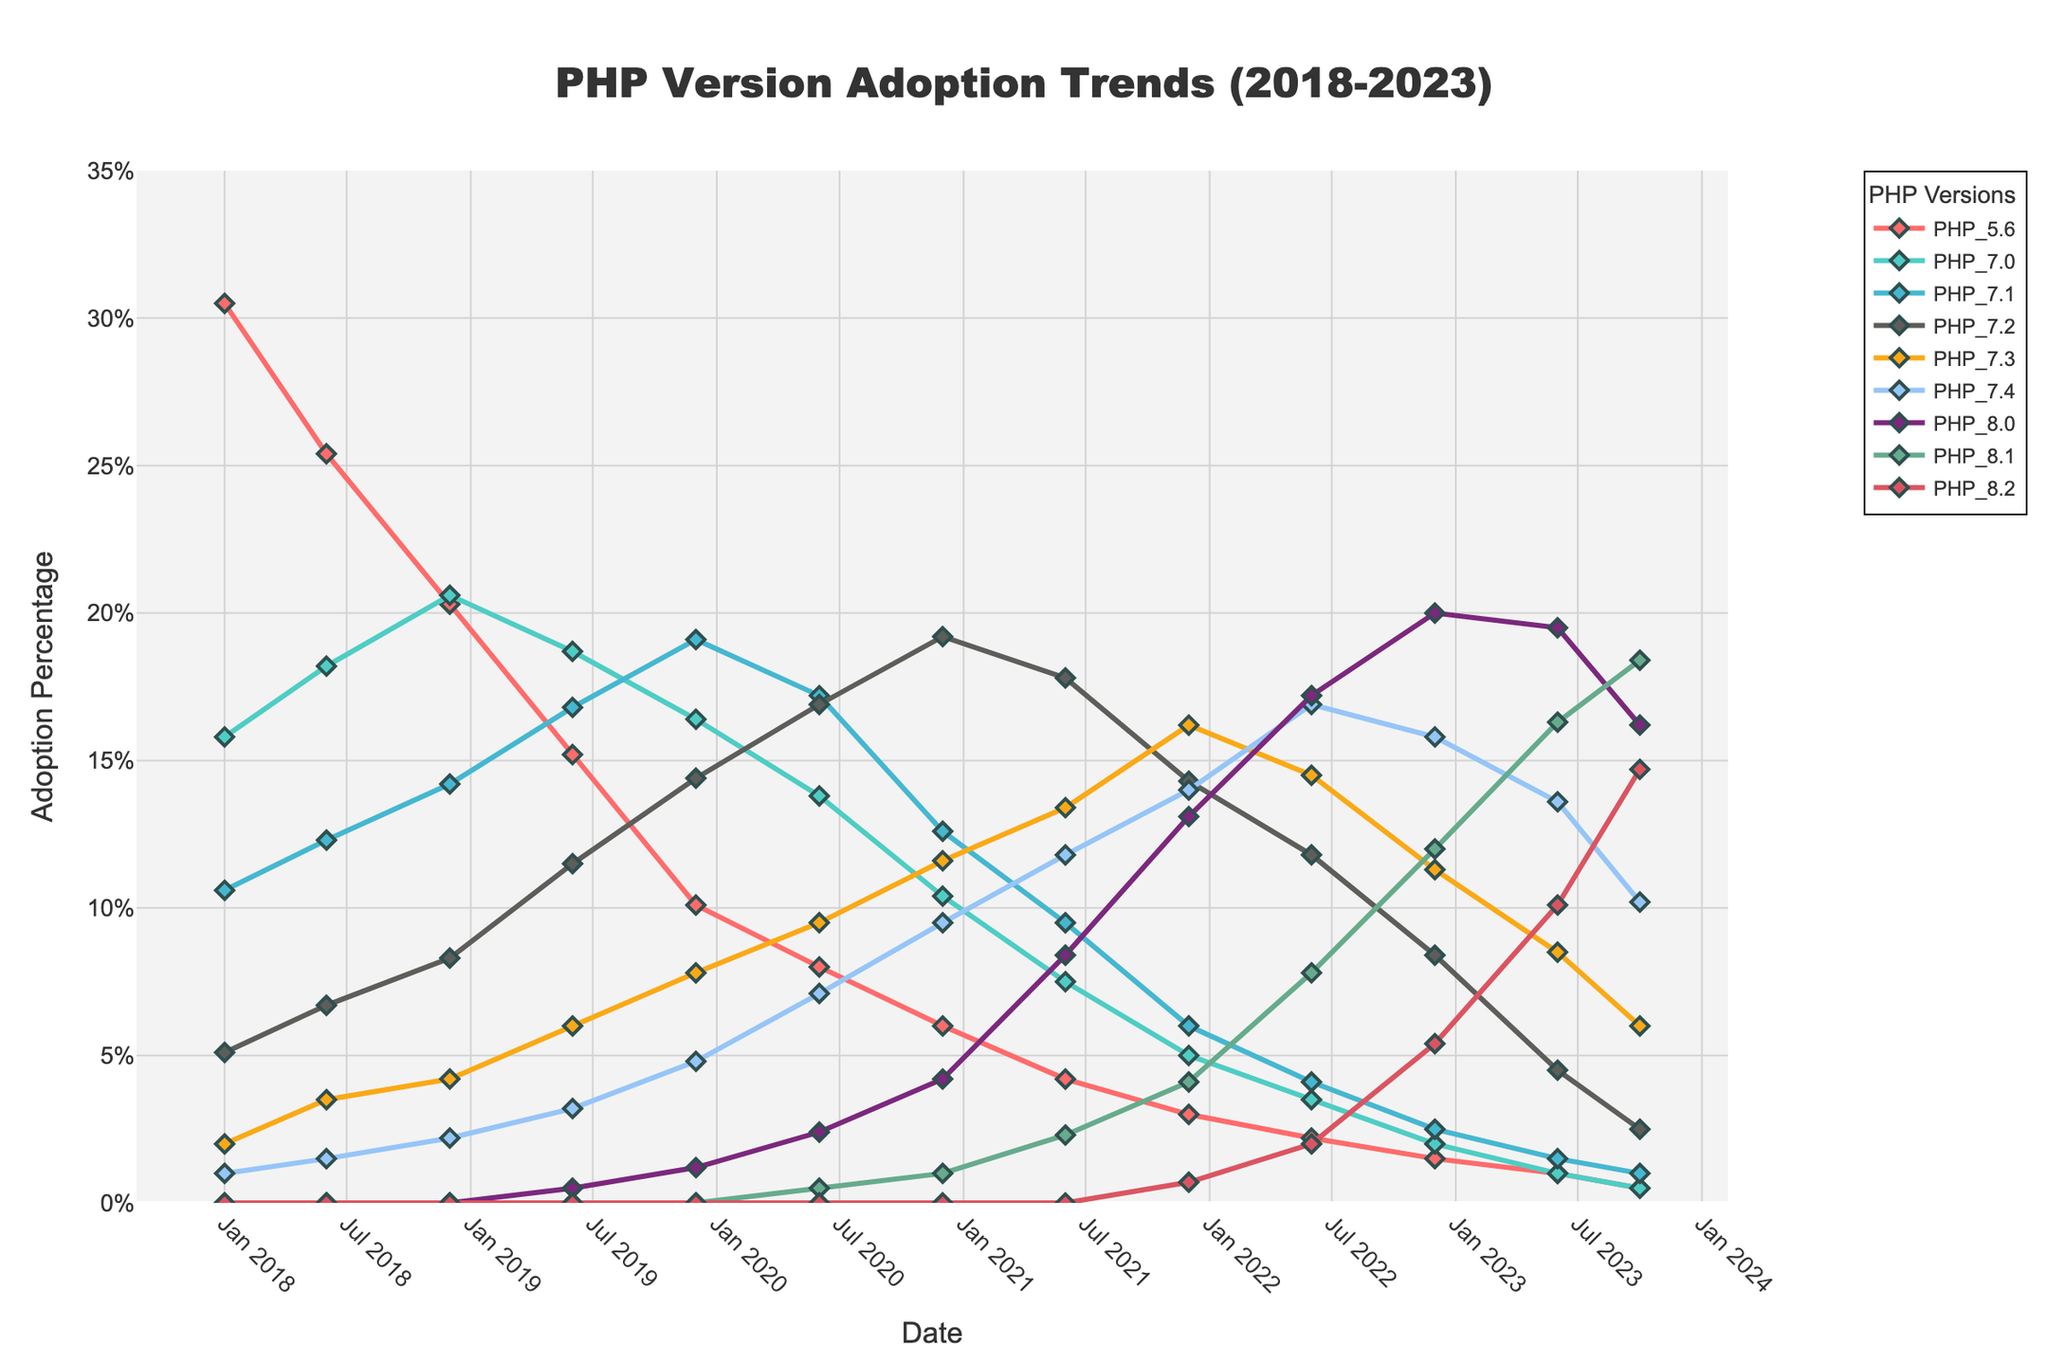What is the title of the figure? The title of the figure is typically located at the top of the plot. In this case, it reads "PHP Version Adoption Trends (2018-2023)" according to the provided code.
Answer: PHP Version Adoption Trends (2018-2023) Which PHP version had the highest adoption percentage in January 2018? To determine this, we look for the highest value in the January 2018 column across all PHP versions listed. PHP 5.6 has the highest adoption at 30.5%.
Answer: PHP 5.6 How did the adoption percentage of PHP 7.4 change from June 2020 to December 2020? To find this, we observe the adoption percentages for PHP 7.4 in June 2020 and December 2020. In June 2020, it was 7.1%, and in December 2020, it was 9.5%, indicating an increase.
Answer: Increased Which PHP version showed the most significant increase in adoption from June 2022 to October 2023? We compare the adoption percentages for each PHP version between June 2022 and October 2023. PHP 8.2 increased from 2.0% in June 2022 to 14.7% in October 2023, showing the most significant increase.
Answer: PHP 8.2 Between which two consecutive dates did PHP 8.1 see the highest increase in adoption percentage? We inspect the values for PHP 8.1 and note the changes between consecutive dates. The highest increase occurred between December 2022 (12.0%) and June 2023 (16.3%), an increase of 4.3%.
Answer: December 2022 to June 2023 What was the adoption percentage of PHP 8.0 in the latest recorded month? The latest recorded month in the data is October 2023, and the adoption percentage of PHP 8.0 during this time was 16.2%.
Answer: 16.2% What is the general trend for PHP 5.6 from 2018 to 2023? Observing the data for PHP 5.6 from 2018 to 2023 shows a continuous decline in adoption percentage, starting at 30.5% in January 2018 and dropping to 0.5% by October 2023.
Answer: Declining How did the adoption percentages of PHP 7.3 and PHP 8.1 compare in June 2023? For June 2023, PHP 7.3 had an adoption percentage of 8.5%, while PHP 8.1 had 16.3%. Thus, PHP 8.1 had a higher adoption percentage than PHP 7.3.
Answer: PHP 8.1 had higher adoption Which two PHP versions had the smallest adoption rates in December 2022 and what were their percentages? To find the smallest adoption rates, we look at the values for each PHP version in December 2022. PHP 5.6 and PHP 7.0 had the smallest adoption rates with 1.5% and 2.0%, respectively.
Answer: PHP 5.6 (1.5%) and PHP 7.0 (2.0%) What has been the trend for PHP 7.4 since its release? Observing the data starting from when PHP 7.4 first appears in January 2018 with 1.0%, there has been a mostly increasing trend, reaching its peak at 16.9% in June 2022, and showing a slight decline to 10.2% by October 2023.
Answer: Mostly increasing, slight recent decline 